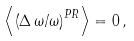<formula> <loc_0><loc_0><loc_500><loc_500>\left \langle \left ( \Delta \, \omega / \omega \right ) ^ { P R } \right \rangle = 0 \, ,</formula> 